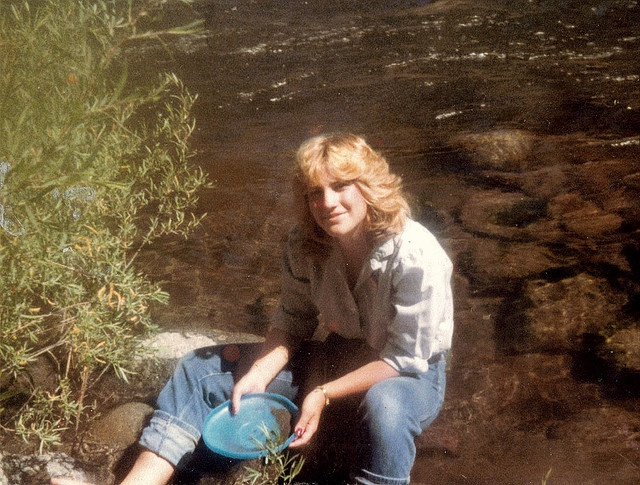Describe the objects in this image and their specific colors. I can see people in olive, maroon, ivory, black, and darkgray tones and frisbee in olive, darkgray, lightblue, and gray tones in this image. 